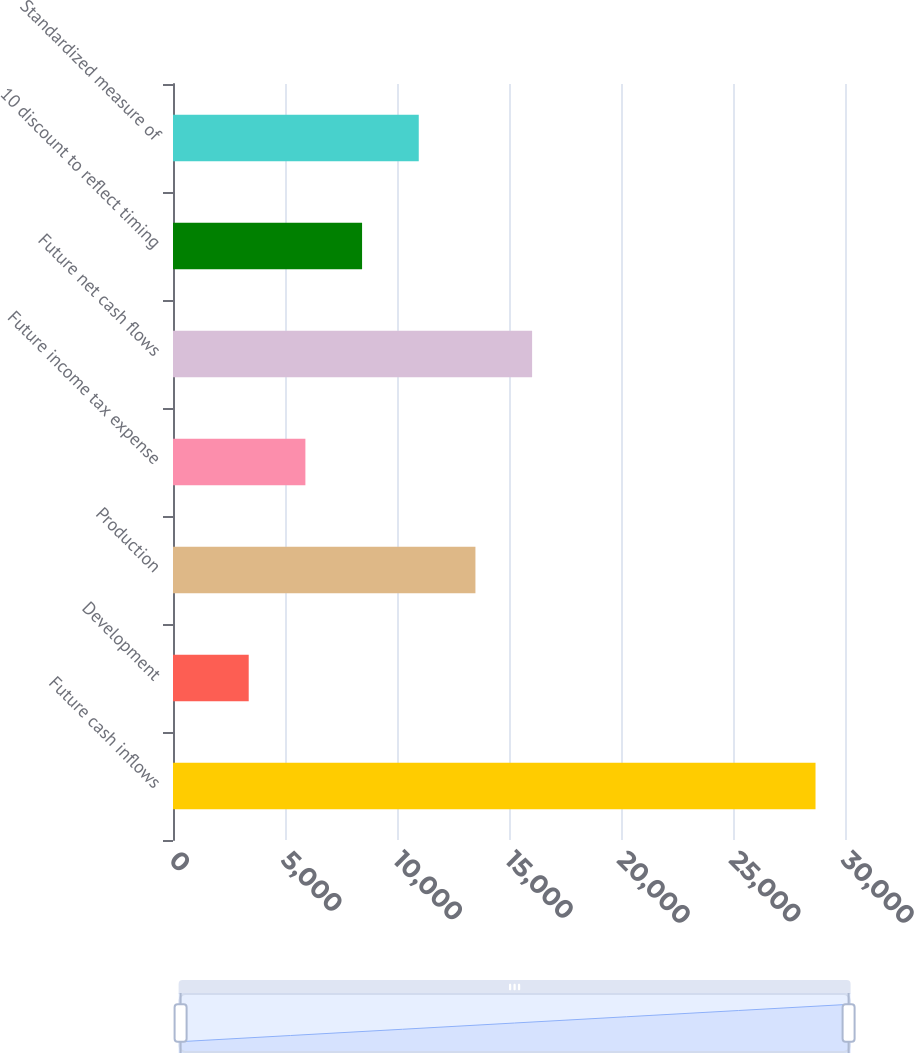Convert chart. <chart><loc_0><loc_0><loc_500><loc_500><bar_chart><fcel>Future cash inflows<fcel>Development<fcel>Production<fcel>Future income tax expense<fcel>Future net cash flows<fcel>10 discount to reflect timing<fcel>Standardized measure of<nl><fcel>28684<fcel>3380<fcel>13501.6<fcel>5910.4<fcel>16032<fcel>8440.8<fcel>10971.2<nl></chart> 